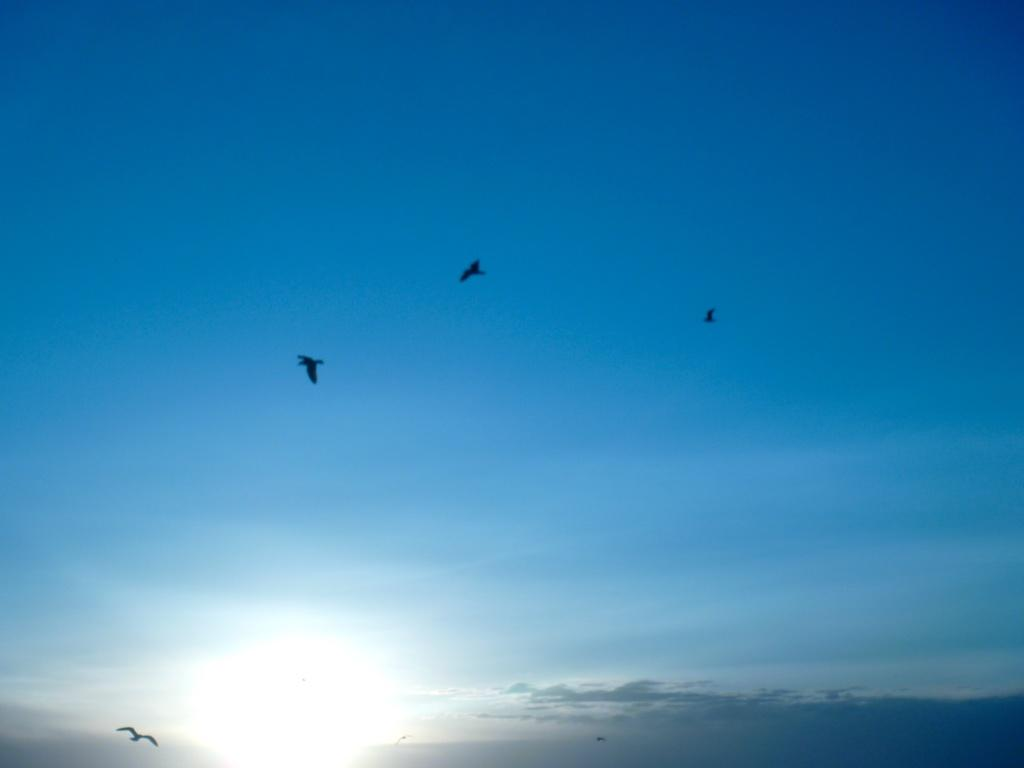What is happening in the image? There are birds flying in the image. How would you describe the sky in the image? The sky is blue and cloudy in the image. Can you see any sea creatures swimming in the image? There is no sea or sea creatures present in the image; it features birds flying in a blue and cloudy sky. What type of goose can be seen in the image? There is no goose present in the image; it features birds flying in a blue and cloudy sky. 